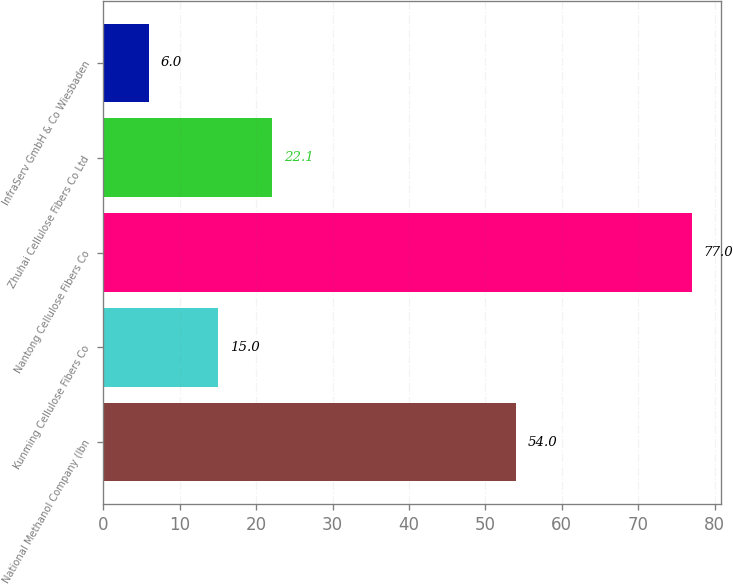Convert chart. <chart><loc_0><loc_0><loc_500><loc_500><bar_chart><fcel>National Methanol Company (Ibn<fcel>Kunming Cellulose Fibers Co<fcel>Nantong Cellulose Fibers Co<fcel>Zhuhai Cellulose Fibers Co Ltd<fcel>InfraServ GmbH & Co Wiesbaden<nl><fcel>54<fcel>15<fcel>77<fcel>22.1<fcel>6<nl></chart> 